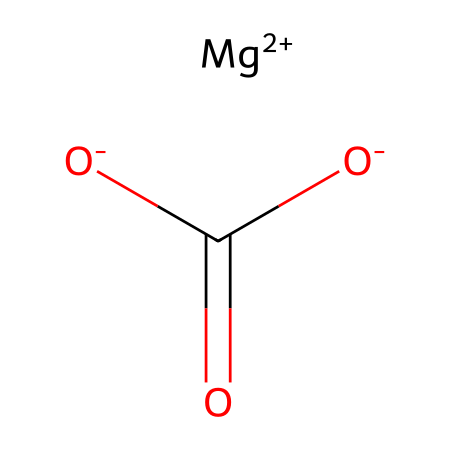What is the molecular formula of this chemical? The SMILES representation presents magnesium (Mg) and carbonate (CO3) ions. Therefore, the combination yields the formula MgCO3.
Answer: MgCO3 How many oxygen atoms are present in this compound? Inspecting the structure derived from the SMILES notation, there are three oxygen atoms shown as part of the carbonate ion (CO3).
Answer: 3 What type of bond connects magnesium to carbonate? The magnesium ion is ionically bonded to the carbonate ion due to the transfer of charge (Mg2+ to CO3^2-), characteristic of ionic bonds.
Answer: ionic Is this chemical considered hazardous? Magnesium carbonate itself is generally not hazardous, but as a chalk, it can cause respiratory issues if inhaled in large quantities, warranting caution.
Answer: yes What is the charge of the magnesium ion in this compound? The SMILES indicates that magnesium has a +2 charge ([Mg+2]), indicating it is a divalent cation in the compound.
Answer: +2 What physical state is magnesium carbonate typically found in? As climbing chalk, magnesium carbonate is usually a solid powder that readily occurs in crystals.
Answer: solid What is the primary use of this chemical among climbers? Climbers use magnesium carbonate primarily for improving grip by absorbing moisture on the hands, thereby preventing slips.
Answer: grip improvement 